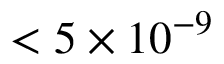<formula> <loc_0><loc_0><loc_500><loc_500>< 5 \times 1 0 ^ { - 9 }</formula> 